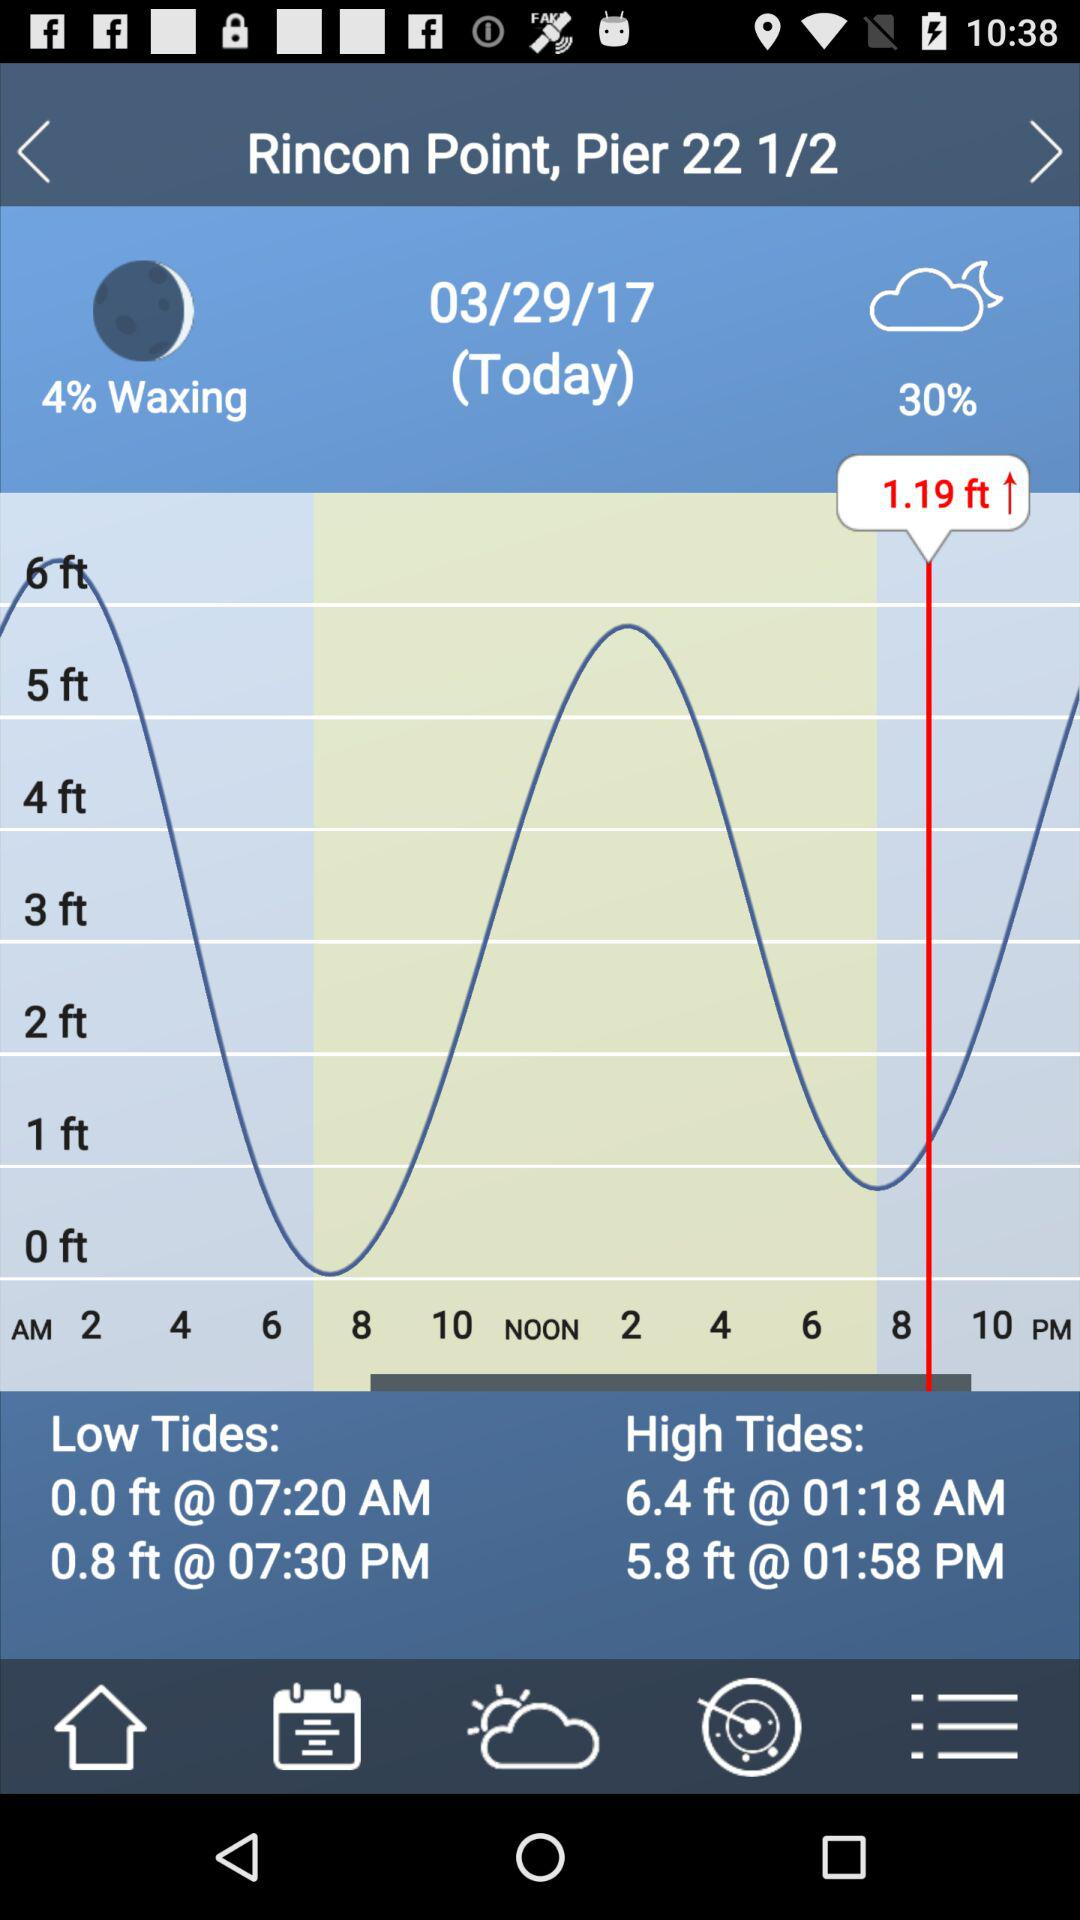How much waxing percentage is given on the screen? The given waxing percentage is 4. 